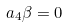<formula> <loc_0><loc_0><loc_500><loc_500>a _ { 4 } \beta = 0</formula> 